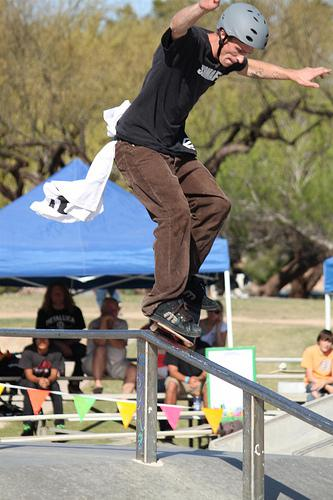Question: what color is the skaters helmet?
Choices:
A. His helmet is yellow.
B. His helmet is white.
C. His helmet is grey.
D. His helmet is brown.
Answer with the letter. Answer: C Question: what color is the rail?
Choices:
A. The rail is white.
B. The rail is black.
C. The rail is silver.
D. The rail is brown.
Answer with the letter. Answer: C Question: where was this picture taken?
Choices:
A. The beach.
B. The skating rink.
C. It was taken at the skate park.
D. A mountain.
Answer with the letter. Answer: C 